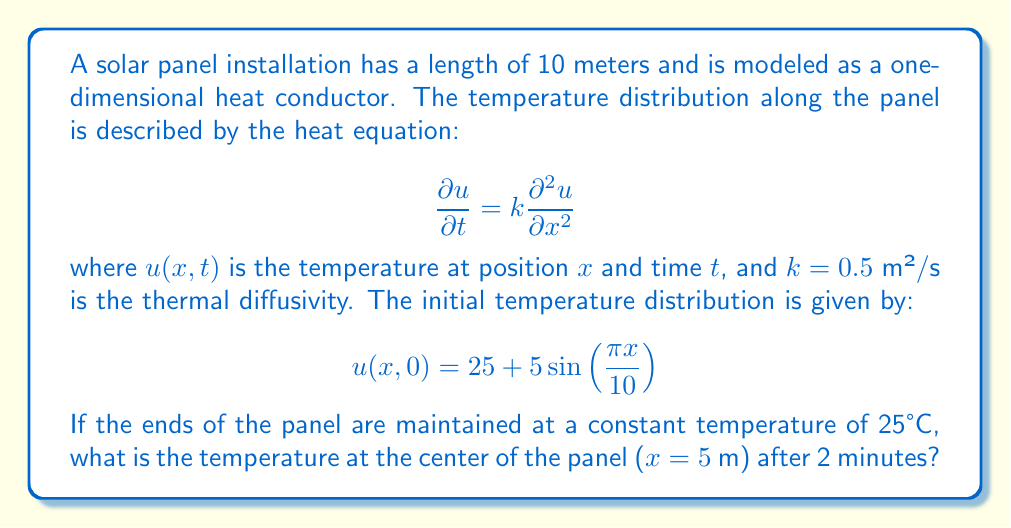Help me with this question. To solve this problem, we need to use the method of separation of variables for the heat equation with the given initial and boundary conditions.

Step 1: Set up the boundary value problem
- Heat equation: $\frac{\partial u}{\partial t} = k\frac{\partial^2 u}{\partial x^2}$
- Initial condition: $u(x,0) = 25 + 5\sin(\frac{\pi x}{10})$
- Boundary conditions: $u(0,t) = u(10,t) = 25$

Step 2: Separate variables
Let $u(x,t) = X(x)T(t)$. Substituting this into the heat equation:

$$X(x)T'(t) = kX''(x)T(t)$$

Dividing both sides by $kX(x)T(t)$:

$$\frac{T'(t)}{kT(t)} = \frac{X''(x)}{X(x)} = -\lambda$$

Where $-\lambda$ is a separation constant.

Step 3: Solve the spatial equation
$X''(x) + \lambda X(x) = 0$
With boundary conditions: $X(0) = X(10) = 0$

The general solution is:
$X(x) = A\sin(\sqrt{\lambda}x) + B\cos(\sqrt{\lambda}x)$

Applying the boundary conditions:
$X(0) = 0 \implies B = 0$
$X(10) = 0 \implies A\sin(10\sqrt{\lambda}) = 0$

This gives us $\sqrt{\lambda} = \frac{n\pi}{10}$, where $n$ is a positive integer.

Step 4: Solve the time equation
$T'(t) + k\lambda T(t) = 0$

The solution is:
$T(t) = Ce^{-k\lambda t} = Ce^{-k(\frac{n\pi}{10})^2t}$

Step 5: Combine the solutions
The general solution is:

$$u(x,t) = \sum_{n=1}^{\infty} C_n \sin(\frac{n\pi x}{10})e^{-k(\frac{n\pi}{10})^2t}$$

Step 6: Apply the initial condition to find $C_n$
$u(x,0) = 25 + 5\sin(\frac{\pi x}{10}) = \sum_{n=1}^{\infty} C_n \sin(\frac{n\pi x}{10})$

This implies:
$C_1 = 5$, $C_n = 0$ for $n > 1$

Step 7: Write the final solution
$$u(x,t) = 25 + 5\sin(\frac{\pi x}{10})e^{-k(\frac{\pi}{10})^2t}$$

Step 8: Calculate the temperature at $x = 5$ m and $t = 120$ s
$$u(5,120) = 25 + 5\sin(\frac{\pi \cdot 5}{10})e^{-0.5(\frac{\pi}{10})^2 \cdot 120}$$

$$u(5,120) = 25 + 5 \cdot e^{-0.5(\frac{\pi}{10})^2 \cdot 120}$$

$$u(5,120) \approx 28.16°C$$
Answer: 28.16°C 